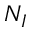Convert formula to latex. <formula><loc_0><loc_0><loc_500><loc_500>N _ { I }</formula> 